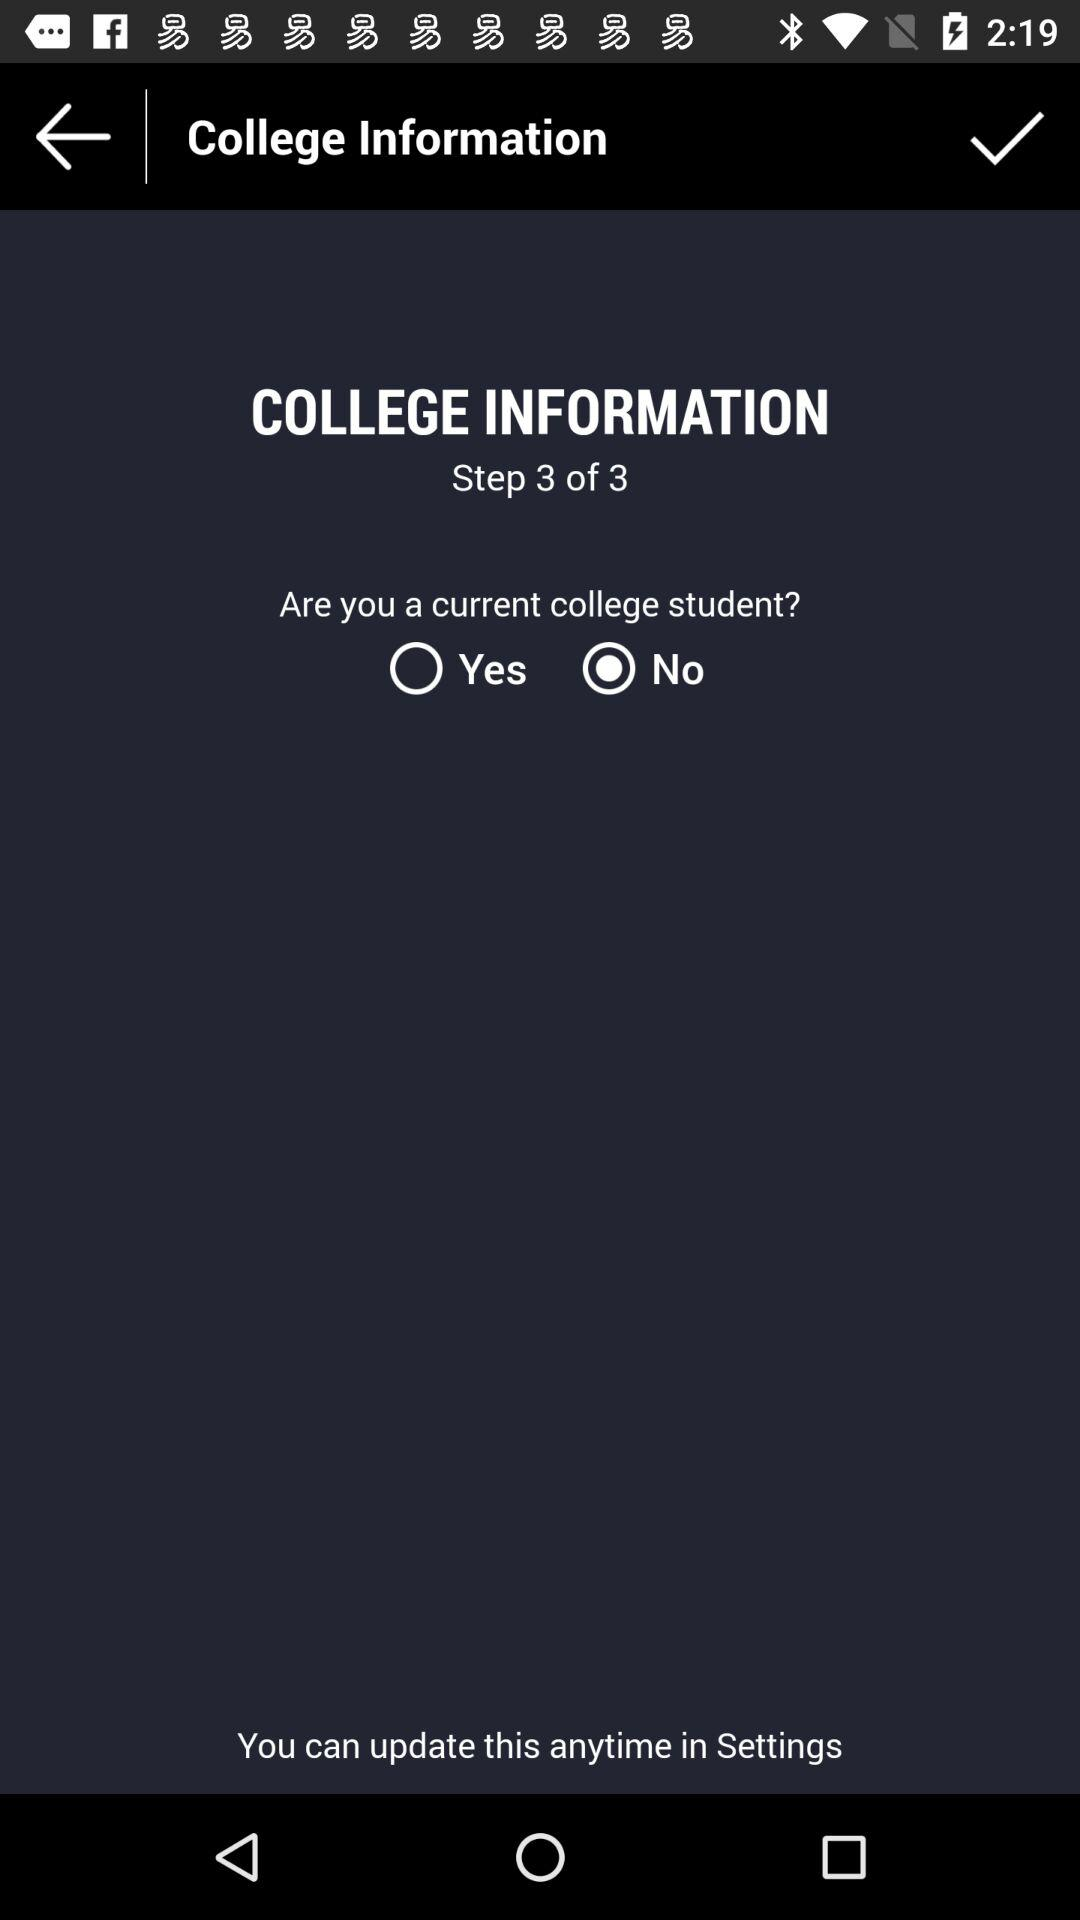How many steps are there in this process?
Answer the question using a single word or phrase. 3 